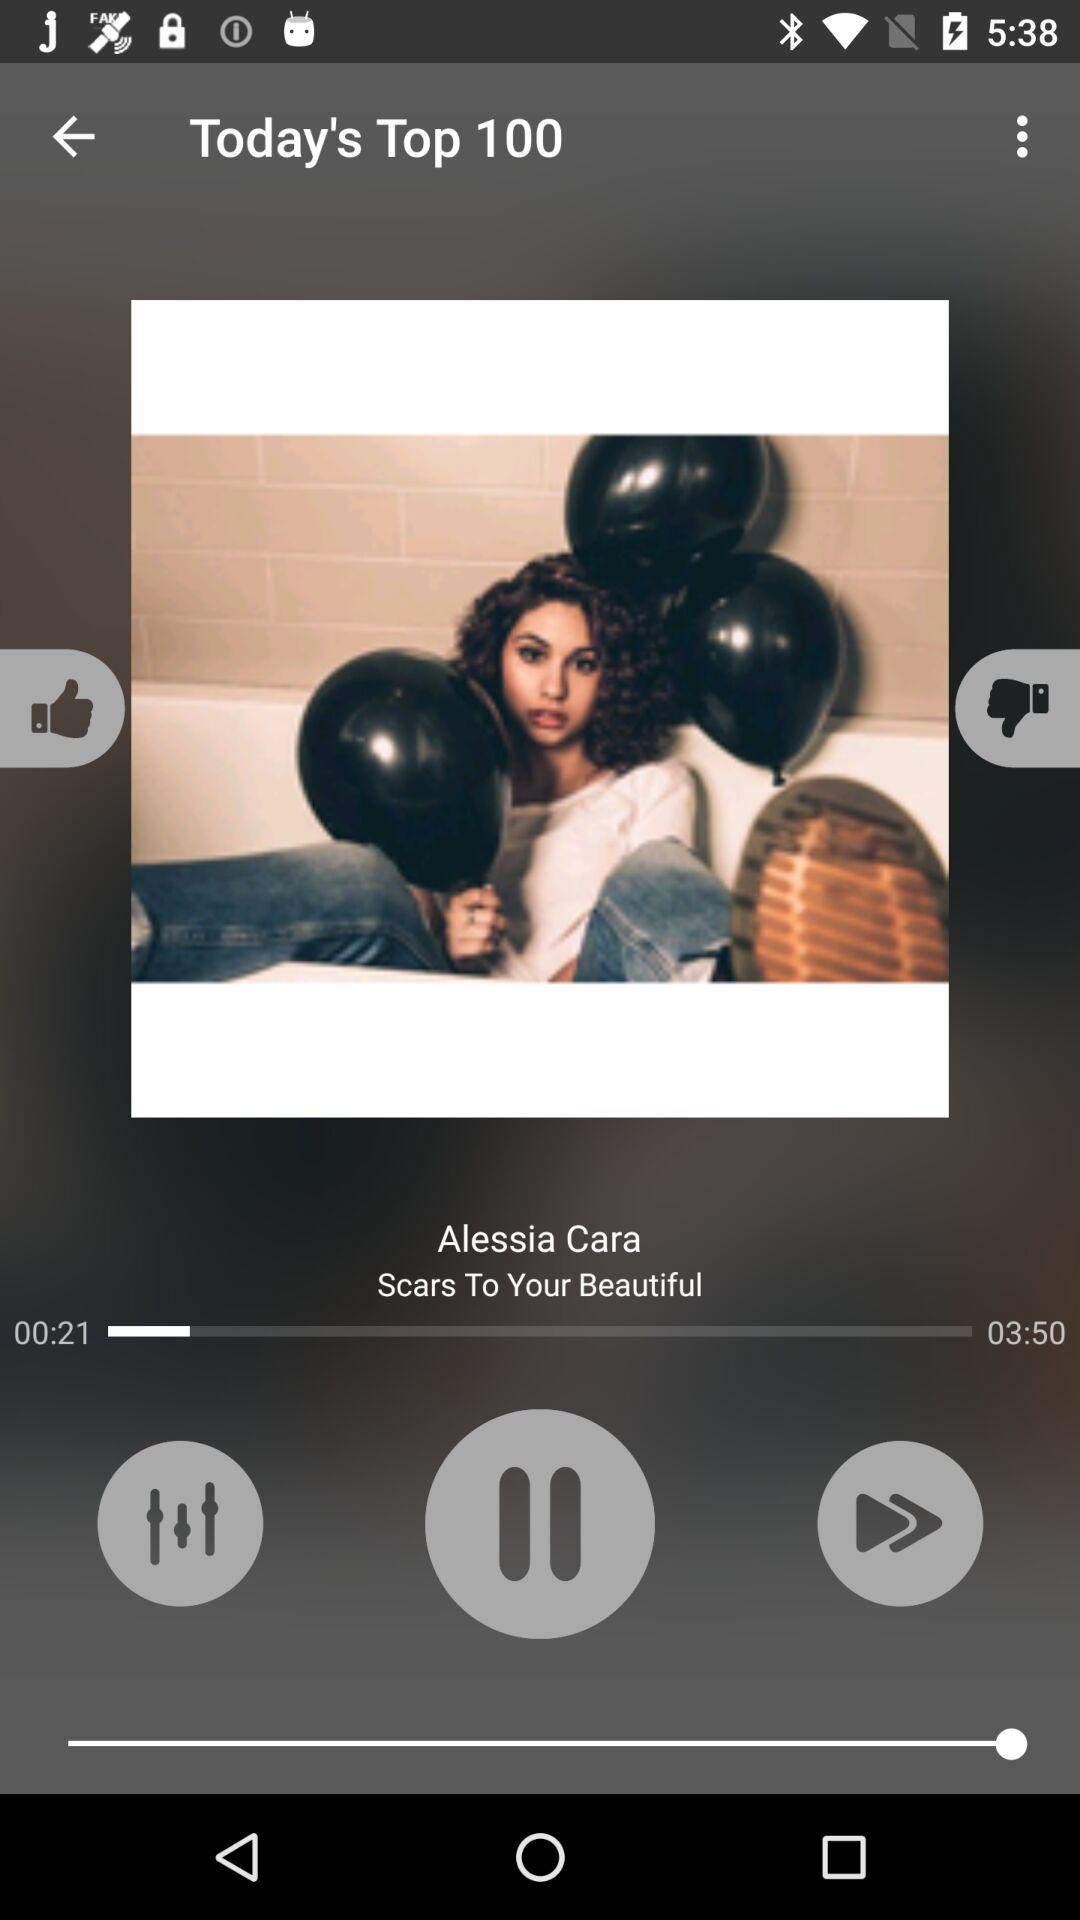What is the song album name?
When the provided information is insufficient, respond with <no answer>. <no answer> 